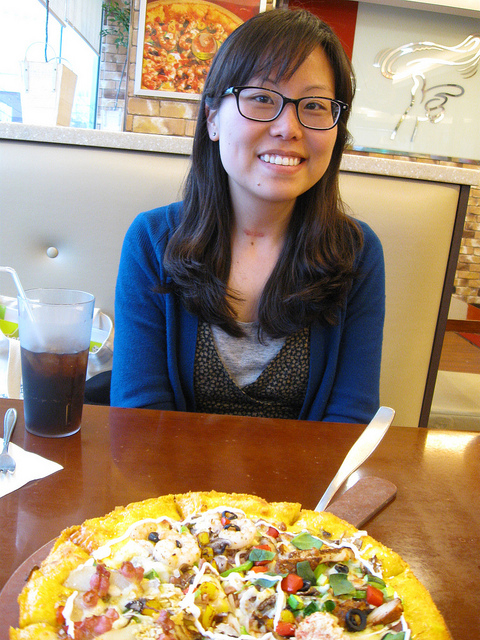What kind of pizza is shown in the image? The pizza in the image appears to be a delicious combination, potentially topped with various ingredients like onions, olives, bell peppers, mushrooms, and a sprinkling of meat, possibly sausage or pepperoni. It seems to be a feast for those who enjoy a hearty, loaded pizza. 